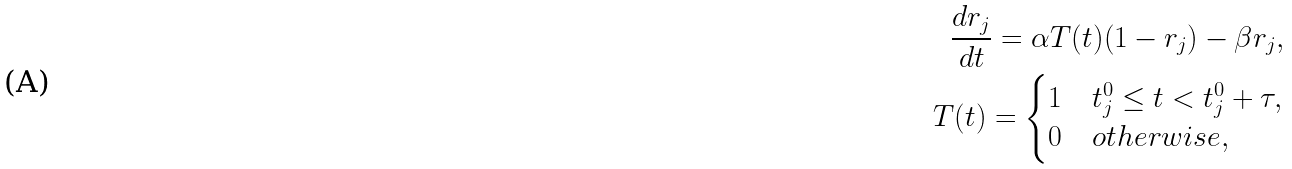<formula> <loc_0><loc_0><loc_500><loc_500>\frac { d r _ { j } } { d t } = \alpha T ( t ) ( 1 - r _ { j } ) - \beta r _ { j } , \\ T ( t ) = \begin{cases} 1 & t _ { j } ^ { 0 } \leq t < t _ { j } ^ { 0 } + \tau , \\ 0 & o t h e r w i s e , \end{cases}</formula> 